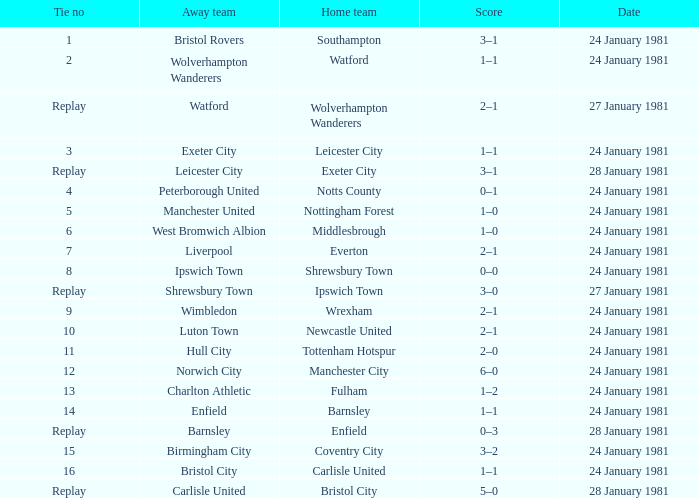What is the score when the tie is 8? 0–0. Would you mind parsing the complete table? {'header': ['Tie no', 'Away team', 'Home team', 'Score', 'Date'], 'rows': [['1', 'Bristol Rovers', 'Southampton', '3–1', '24 January 1981'], ['2', 'Wolverhampton Wanderers', 'Watford', '1–1', '24 January 1981'], ['Replay', 'Watford', 'Wolverhampton Wanderers', '2–1', '27 January 1981'], ['3', 'Exeter City', 'Leicester City', '1–1', '24 January 1981'], ['Replay', 'Leicester City', 'Exeter City', '3–1', '28 January 1981'], ['4', 'Peterborough United', 'Notts County', '0–1', '24 January 1981'], ['5', 'Manchester United', 'Nottingham Forest', '1–0', '24 January 1981'], ['6', 'West Bromwich Albion', 'Middlesbrough', '1–0', '24 January 1981'], ['7', 'Liverpool', 'Everton', '2–1', '24 January 1981'], ['8', 'Ipswich Town', 'Shrewsbury Town', '0–0', '24 January 1981'], ['Replay', 'Shrewsbury Town', 'Ipswich Town', '3–0', '27 January 1981'], ['9', 'Wimbledon', 'Wrexham', '2–1', '24 January 1981'], ['10', 'Luton Town', 'Newcastle United', '2–1', '24 January 1981'], ['11', 'Hull City', 'Tottenham Hotspur', '2–0', '24 January 1981'], ['12', 'Norwich City', 'Manchester City', '6–0', '24 January 1981'], ['13', 'Charlton Athletic', 'Fulham', '1–2', '24 January 1981'], ['14', 'Enfield', 'Barnsley', '1–1', '24 January 1981'], ['Replay', 'Barnsley', 'Enfield', '0–3', '28 January 1981'], ['15', 'Birmingham City', 'Coventry City', '3–2', '24 January 1981'], ['16', 'Bristol City', 'Carlisle United', '1–1', '24 January 1981'], ['Replay', 'Carlisle United', 'Bristol City', '5–0', '28 January 1981']]} 